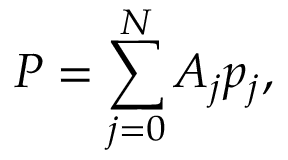<formula> <loc_0><loc_0><loc_500><loc_500>P = \sum _ { j = 0 } ^ { N } A _ { j } p _ { j } ,</formula> 